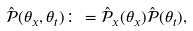Convert formula to latex. <formula><loc_0><loc_0><loc_500><loc_500>\hat { \mathcal { P } } ( \theta _ { x } , \theta _ { t } ) \colon = \hat { \mathcal { P } } _ { x } ( \theta _ { x } ) \hat { \mathcal { P } } ( \theta _ { t } ) ,</formula> 